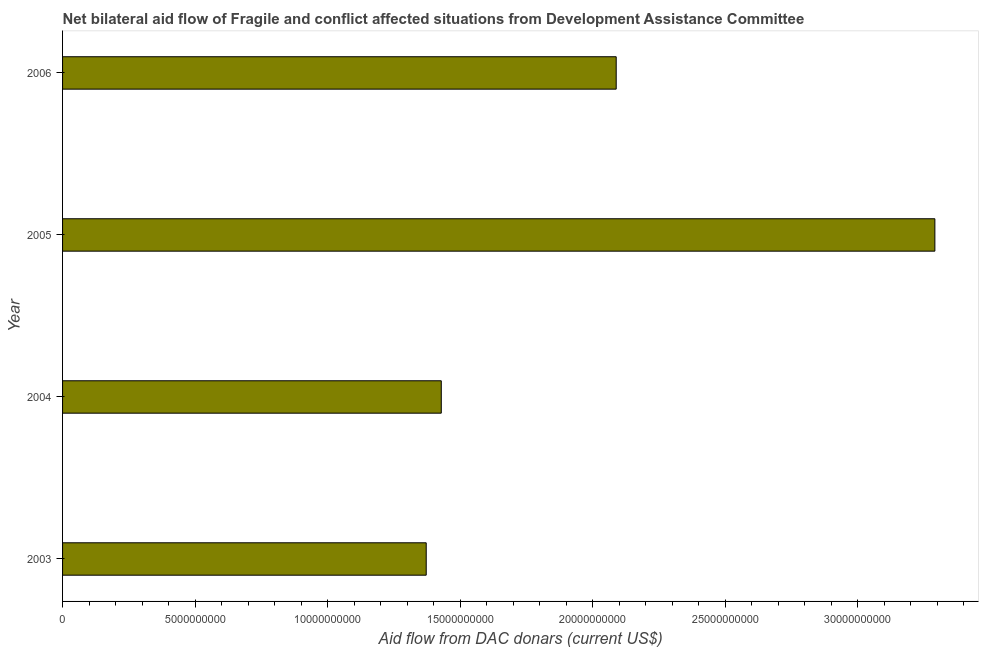Does the graph contain grids?
Your answer should be compact. No. What is the title of the graph?
Offer a terse response. Net bilateral aid flow of Fragile and conflict affected situations from Development Assistance Committee. What is the label or title of the X-axis?
Keep it short and to the point. Aid flow from DAC donars (current US$). What is the net bilateral aid flows from dac donors in 2003?
Your answer should be very brief. 1.37e+1. Across all years, what is the maximum net bilateral aid flows from dac donors?
Ensure brevity in your answer.  3.29e+1. Across all years, what is the minimum net bilateral aid flows from dac donors?
Keep it short and to the point. 1.37e+1. In which year was the net bilateral aid flows from dac donors minimum?
Your answer should be very brief. 2003. What is the sum of the net bilateral aid flows from dac donors?
Your answer should be compact. 8.18e+1. What is the difference between the net bilateral aid flows from dac donors in 2005 and 2006?
Offer a very short reply. 1.20e+1. What is the average net bilateral aid flows from dac donors per year?
Make the answer very short. 2.05e+1. What is the median net bilateral aid flows from dac donors?
Keep it short and to the point. 1.76e+1. In how many years, is the net bilateral aid flows from dac donors greater than 2000000000 US$?
Your response must be concise. 4. Do a majority of the years between 2006 and 2004 (inclusive) have net bilateral aid flows from dac donors greater than 32000000000 US$?
Your response must be concise. Yes. Is the net bilateral aid flows from dac donors in 2005 less than that in 2006?
Keep it short and to the point. No. What is the difference between the highest and the second highest net bilateral aid flows from dac donors?
Your answer should be compact. 1.20e+1. Is the sum of the net bilateral aid flows from dac donors in 2004 and 2006 greater than the maximum net bilateral aid flows from dac donors across all years?
Provide a succinct answer. Yes. What is the difference between the highest and the lowest net bilateral aid flows from dac donors?
Give a very brief answer. 1.92e+1. In how many years, is the net bilateral aid flows from dac donors greater than the average net bilateral aid flows from dac donors taken over all years?
Your answer should be compact. 2. Are all the bars in the graph horizontal?
Give a very brief answer. Yes. How many years are there in the graph?
Offer a very short reply. 4. What is the difference between two consecutive major ticks on the X-axis?
Provide a short and direct response. 5.00e+09. Are the values on the major ticks of X-axis written in scientific E-notation?
Your answer should be very brief. No. What is the Aid flow from DAC donars (current US$) in 2003?
Your answer should be very brief. 1.37e+1. What is the Aid flow from DAC donars (current US$) in 2004?
Make the answer very short. 1.43e+1. What is the Aid flow from DAC donars (current US$) in 2005?
Give a very brief answer. 3.29e+1. What is the Aid flow from DAC donars (current US$) of 2006?
Give a very brief answer. 2.09e+1. What is the difference between the Aid flow from DAC donars (current US$) in 2003 and 2004?
Give a very brief answer. -5.68e+08. What is the difference between the Aid flow from DAC donars (current US$) in 2003 and 2005?
Your answer should be compact. -1.92e+1. What is the difference between the Aid flow from DAC donars (current US$) in 2003 and 2006?
Keep it short and to the point. -7.17e+09. What is the difference between the Aid flow from DAC donars (current US$) in 2004 and 2005?
Your answer should be very brief. -1.86e+1. What is the difference between the Aid flow from DAC donars (current US$) in 2004 and 2006?
Your response must be concise. -6.60e+09. What is the difference between the Aid flow from DAC donars (current US$) in 2005 and 2006?
Your response must be concise. 1.20e+1. What is the ratio of the Aid flow from DAC donars (current US$) in 2003 to that in 2004?
Offer a terse response. 0.96. What is the ratio of the Aid flow from DAC donars (current US$) in 2003 to that in 2005?
Ensure brevity in your answer.  0.42. What is the ratio of the Aid flow from DAC donars (current US$) in 2003 to that in 2006?
Keep it short and to the point. 0.66. What is the ratio of the Aid flow from DAC donars (current US$) in 2004 to that in 2005?
Provide a short and direct response. 0.43. What is the ratio of the Aid flow from DAC donars (current US$) in 2004 to that in 2006?
Your answer should be compact. 0.68. What is the ratio of the Aid flow from DAC donars (current US$) in 2005 to that in 2006?
Give a very brief answer. 1.58. 